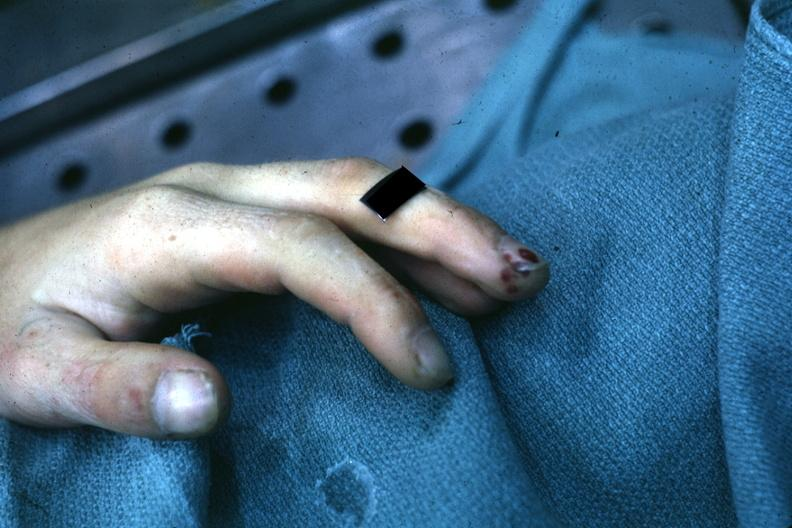what associated with bacterial endocarditis?
Answer the question using a single word or phrase. Very good example of focal necrotizing lesions in distal portion of digit 